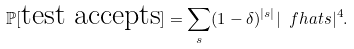Convert formula to latex. <formula><loc_0><loc_0><loc_500><loc_500>\mathbb { P } [ \text {test accepts} ] = \sum _ { s } ( 1 - \delta ) ^ { | s | } | \ f h a t s | ^ { 4 } .</formula> 